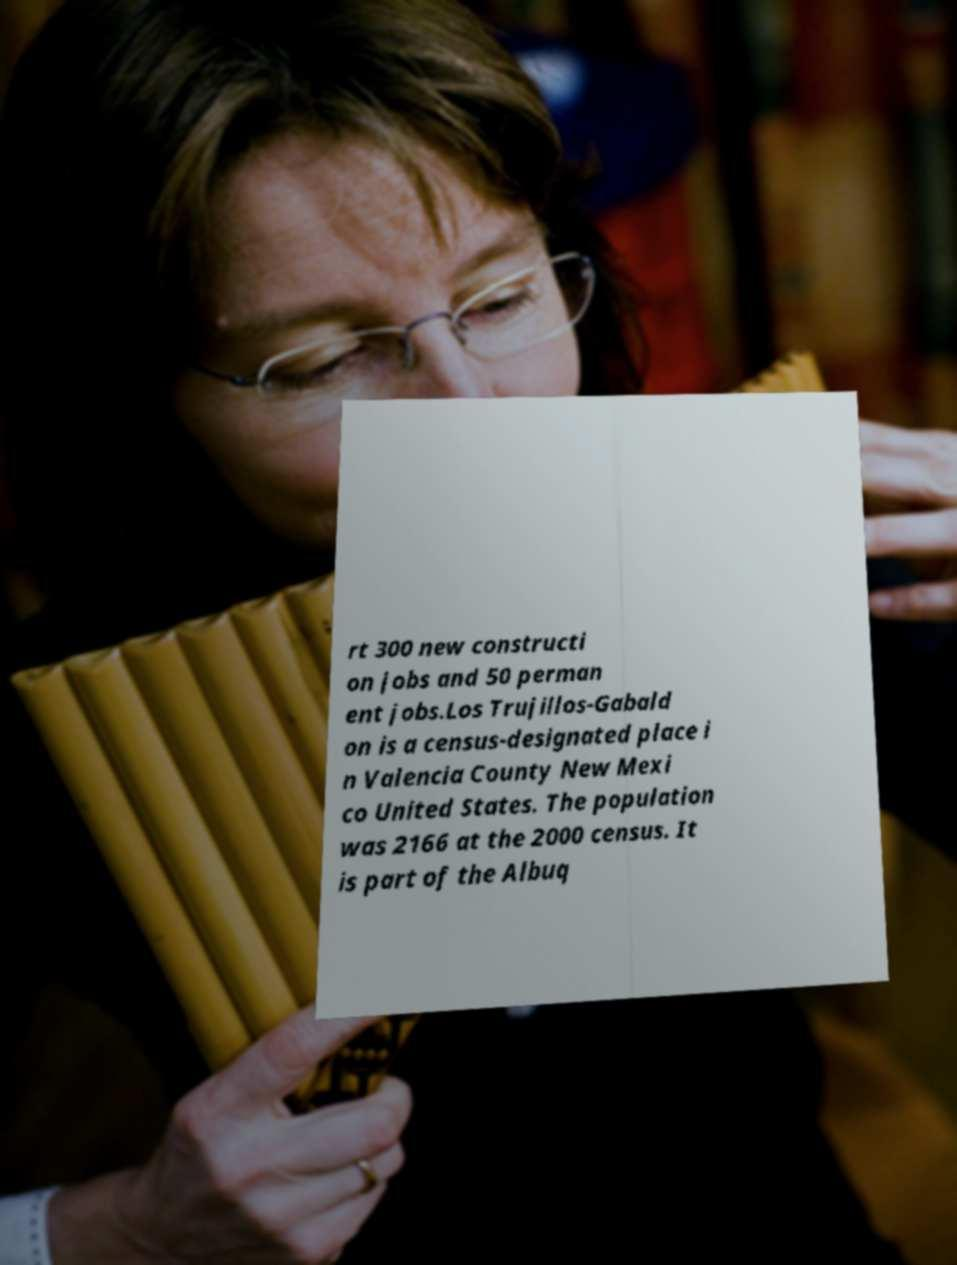Can you accurately transcribe the text from the provided image for me? rt 300 new constructi on jobs and 50 perman ent jobs.Los Trujillos-Gabald on is a census-designated place i n Valencia County New Mexi co United States. The population was 2166 at the 2000 census. It is part of the Albuq 